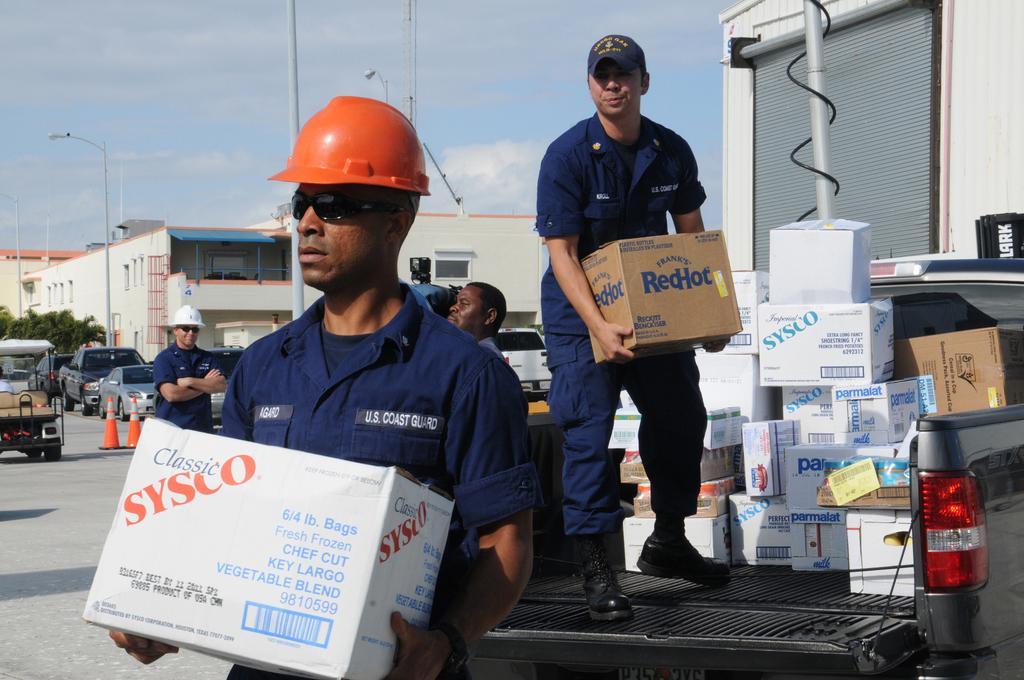How would you summarize this image in a sentence or two? In this image, on the right there is a man, he is holding a box. On the left there is a man, he is holding a box. In the background there are people, street lights, poles, vehicles, boxes, traffic cones, road, buildings, sky and clouds. On the right there is a vehicle on that there are boxes, person. 